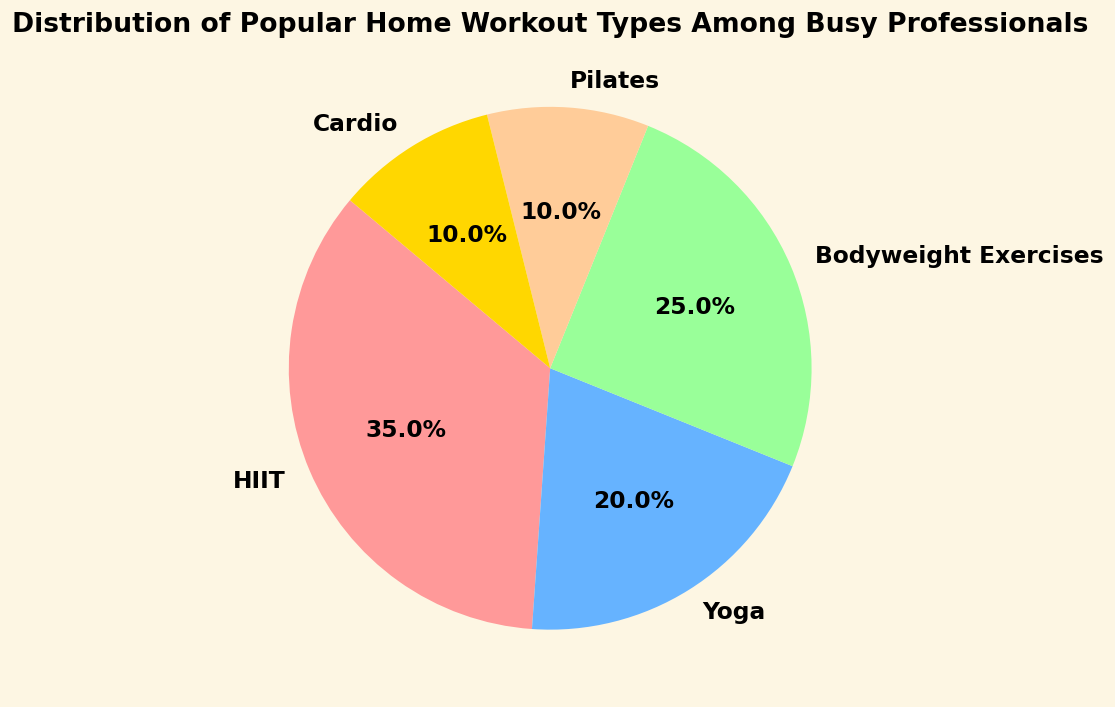Which workout type is the most popular among busy professionals? The figure shows a pie chart with different workout types and their percentage distributions. The largest slice represents HIIT with 35%.
Answer: HIIT Which two workout types have the same percentage distribution? The pie chart visually shows that both Pilates and Cardio have slices of equal size, each making up 10% of the distribution.
Answer: Pilates and Cardio What is the combined percentage of Bodyweight Exercises and Yoga? From the pie chart, Bodyweight Exercises are 25% and Yoga is 20%. Adding these gives 25% + 20% = 45%.
Answer: 45% What is the difference in percentage between the most popular and least popular workout types? The most popular workout type is HIIT at 35% and the least popular types are Pilates and Cardio at 10% each. The difference is 35% - 10% = 25%.
Answer: 25% Are Yoga and Cardio together more popular than Bodyweight Exercises? According to the pie chart, Yoga is 20% and Cardio is 10%. Adding these gives 20% + 10% = 30%. Bodyweight Exercises are 25%, so 30% > 25%.
Answer: Yes What proportion of the distribution is made up by activities other than HIIT? HIIT makes up 35%, so the remaining percentage is 100% - 35% = 65%.
Answer: 65% Which workout type is represented by the darkest color in the pie chart? The pie chart shows HIIT in the darkest shade, depicted as the largest slice of the pie chart.
Answer: HIIT What fraction of busy professionals prefer Yoga or Pilates combined? Yoga is 20% and Pilates is 10%. Combined, these make up 20% + 10% = 30%. In fraction form, this is 30/100 or simplified to 3/10.
Answer: 3/10 How much more popular is HIIT compared to Yoga? HIIT is 35% and Yoga is 20%. The difference is 35% - 20% = 15%.
Answer: 15% 